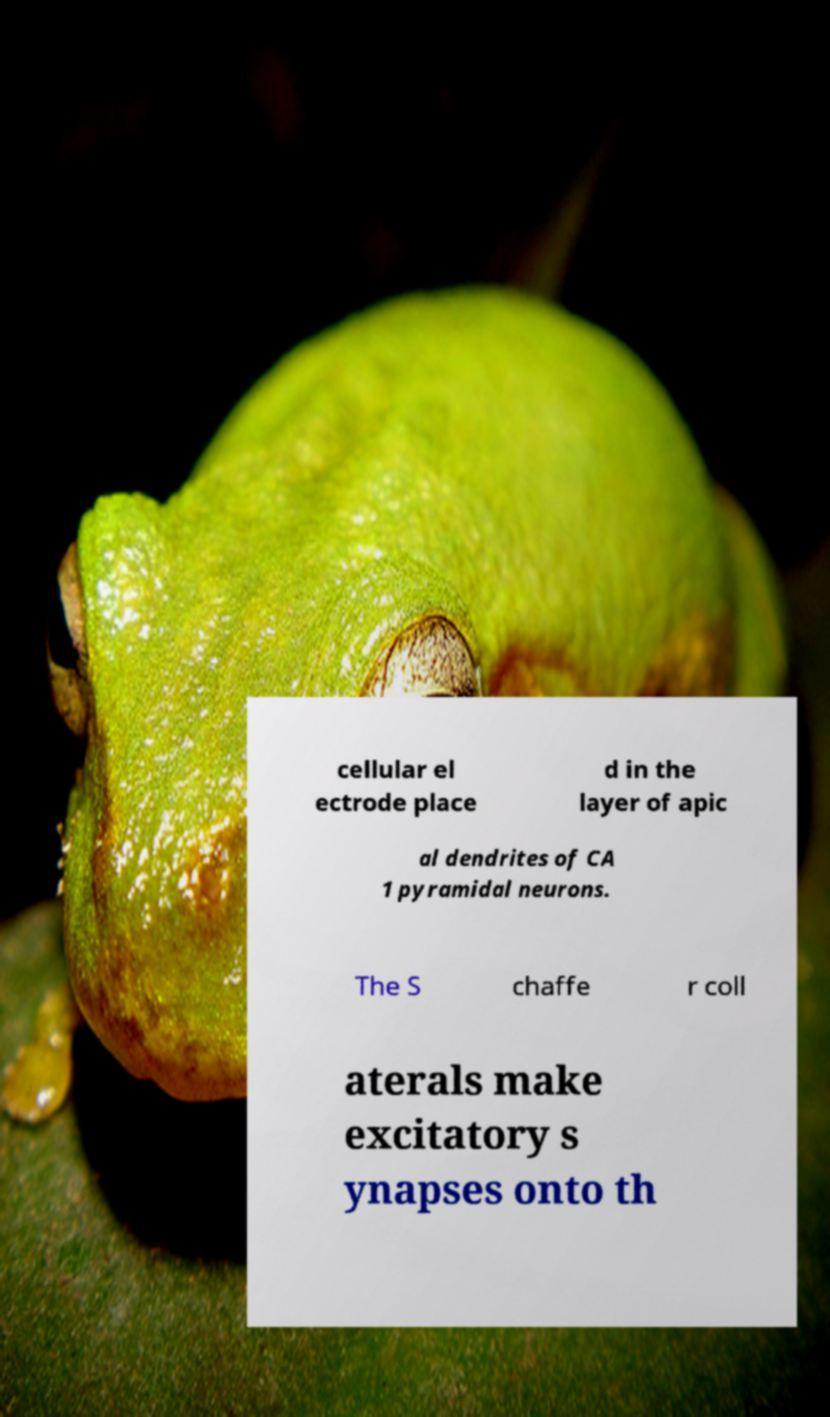There's text embedded in this image that I need extracted. Can you transcribe it verbatim? cellular el ectrode place d in the layer of apic al dendrites of CA 1 pyramidal neurons. The S chaffe r coll aterals make excitatory s ynapses onto th 